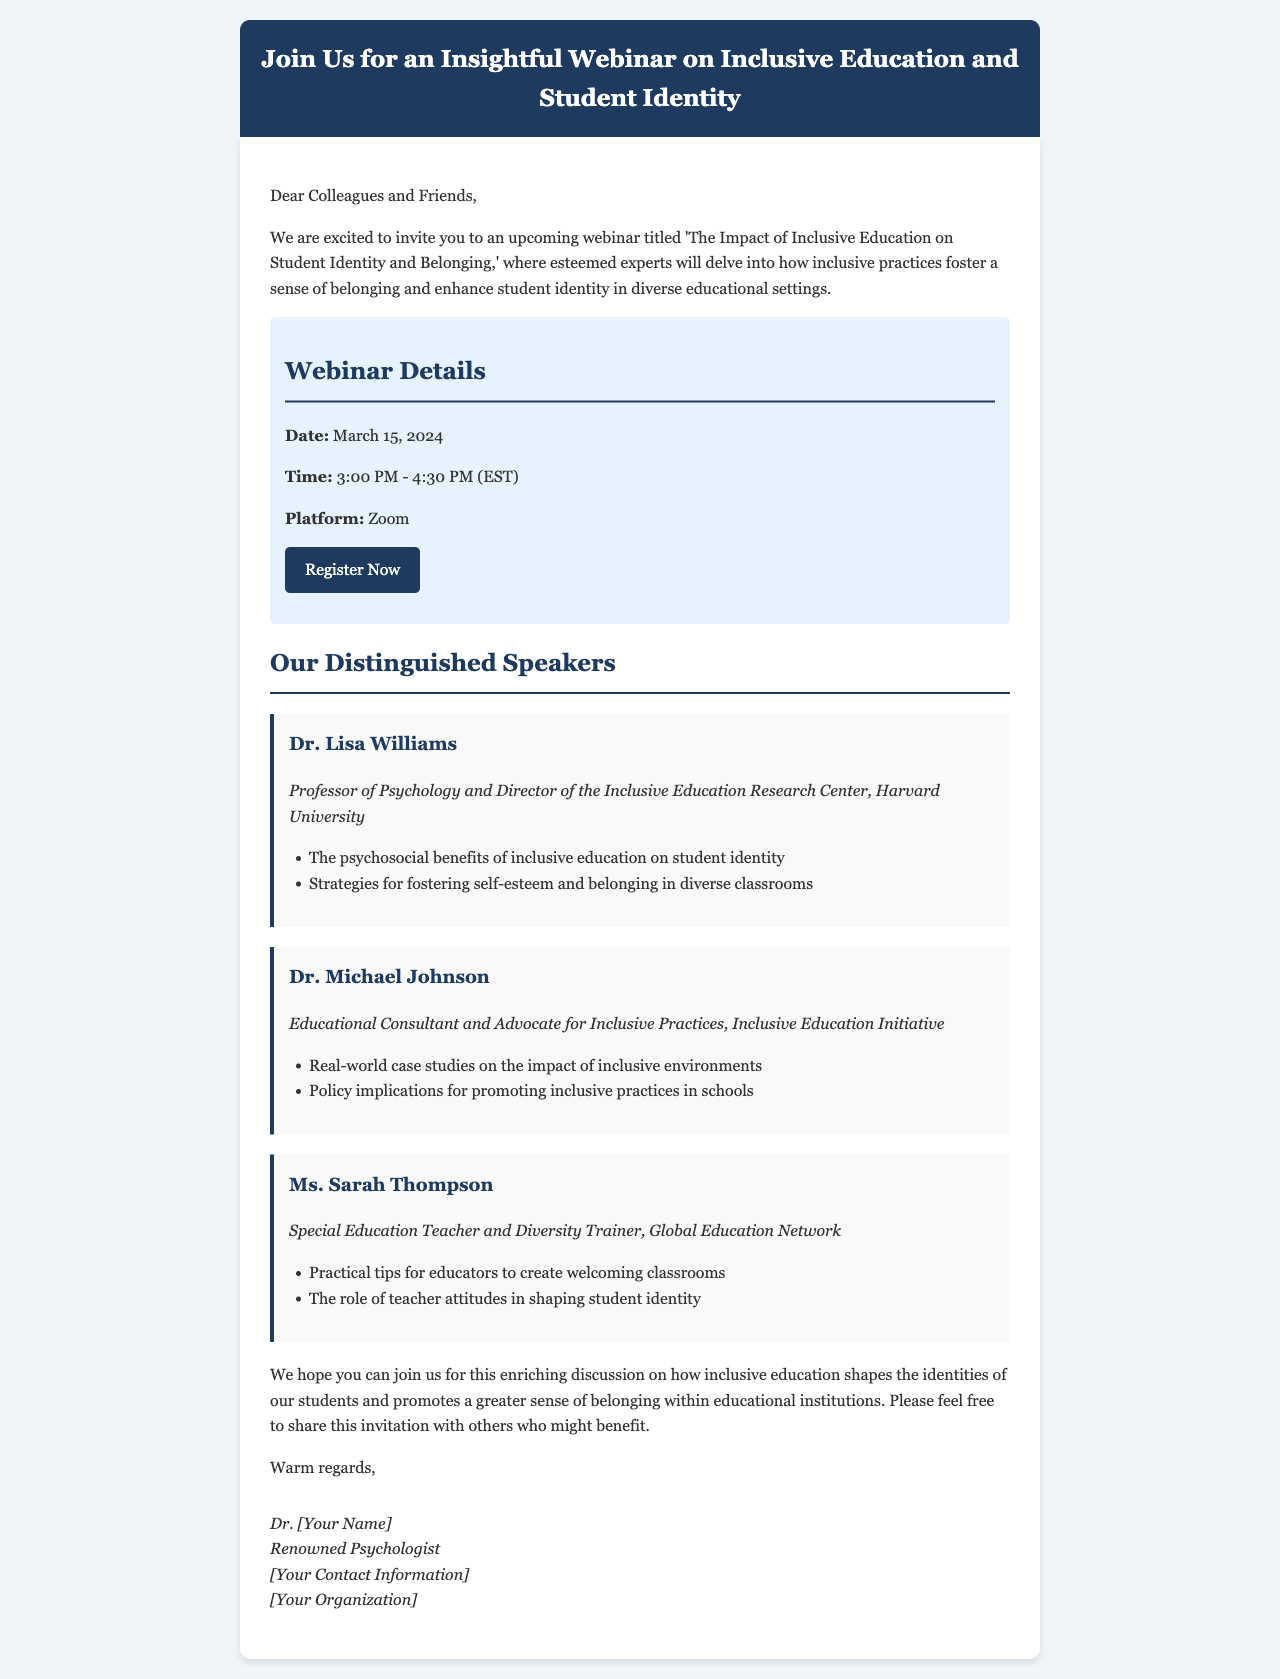What is the date of the webinar? The date of the webinar is mentioned in the "Webinar Details" section.
Answer: March 15, 2024 What time does the webinar start? The start time is specified in the "Webinar Details" section of the email.
Answer: 3:00 PM Who is the first speaker listed? The first speaker's name is given in the "Our Distinguished Speakers" section.
Answer: Dr. Lisa Williams What is one topic Dr. Michael Johnson will discuss? This information is found in the list of topics under Dr. Michael Johnson's details.
Answer: Real-world case studies on the impact of inclusive environments What platform will the webinar be held on? The platform is clearly stated in the "Webinar Details" section.
Answer: Zoom How long is the webinar scheduled to last? The duration can be inferred from the start and end times provided.
Answer: 1 hour 30 minutes What organization is Dr. Lisa Williams associated with? This is mentioned in her description under the "Our Distinguished Speakers" section.
Answer: Harvard University What does the invitation encourage recipients to do? The invitation includes a request directed towards the recipients in the closing paragraphs.
Answer: Share this invitation What type of professionals are the speakers? This can be gathered from the titles provided in the speaker descriptions.
Answer: Experts in psychology and education 